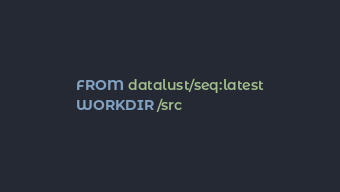<code> <loc_0><loc_0><loc_500><loc_500><_Dockerfile_>FROM datalust/seq:latest
WORKDIR /src</code> 